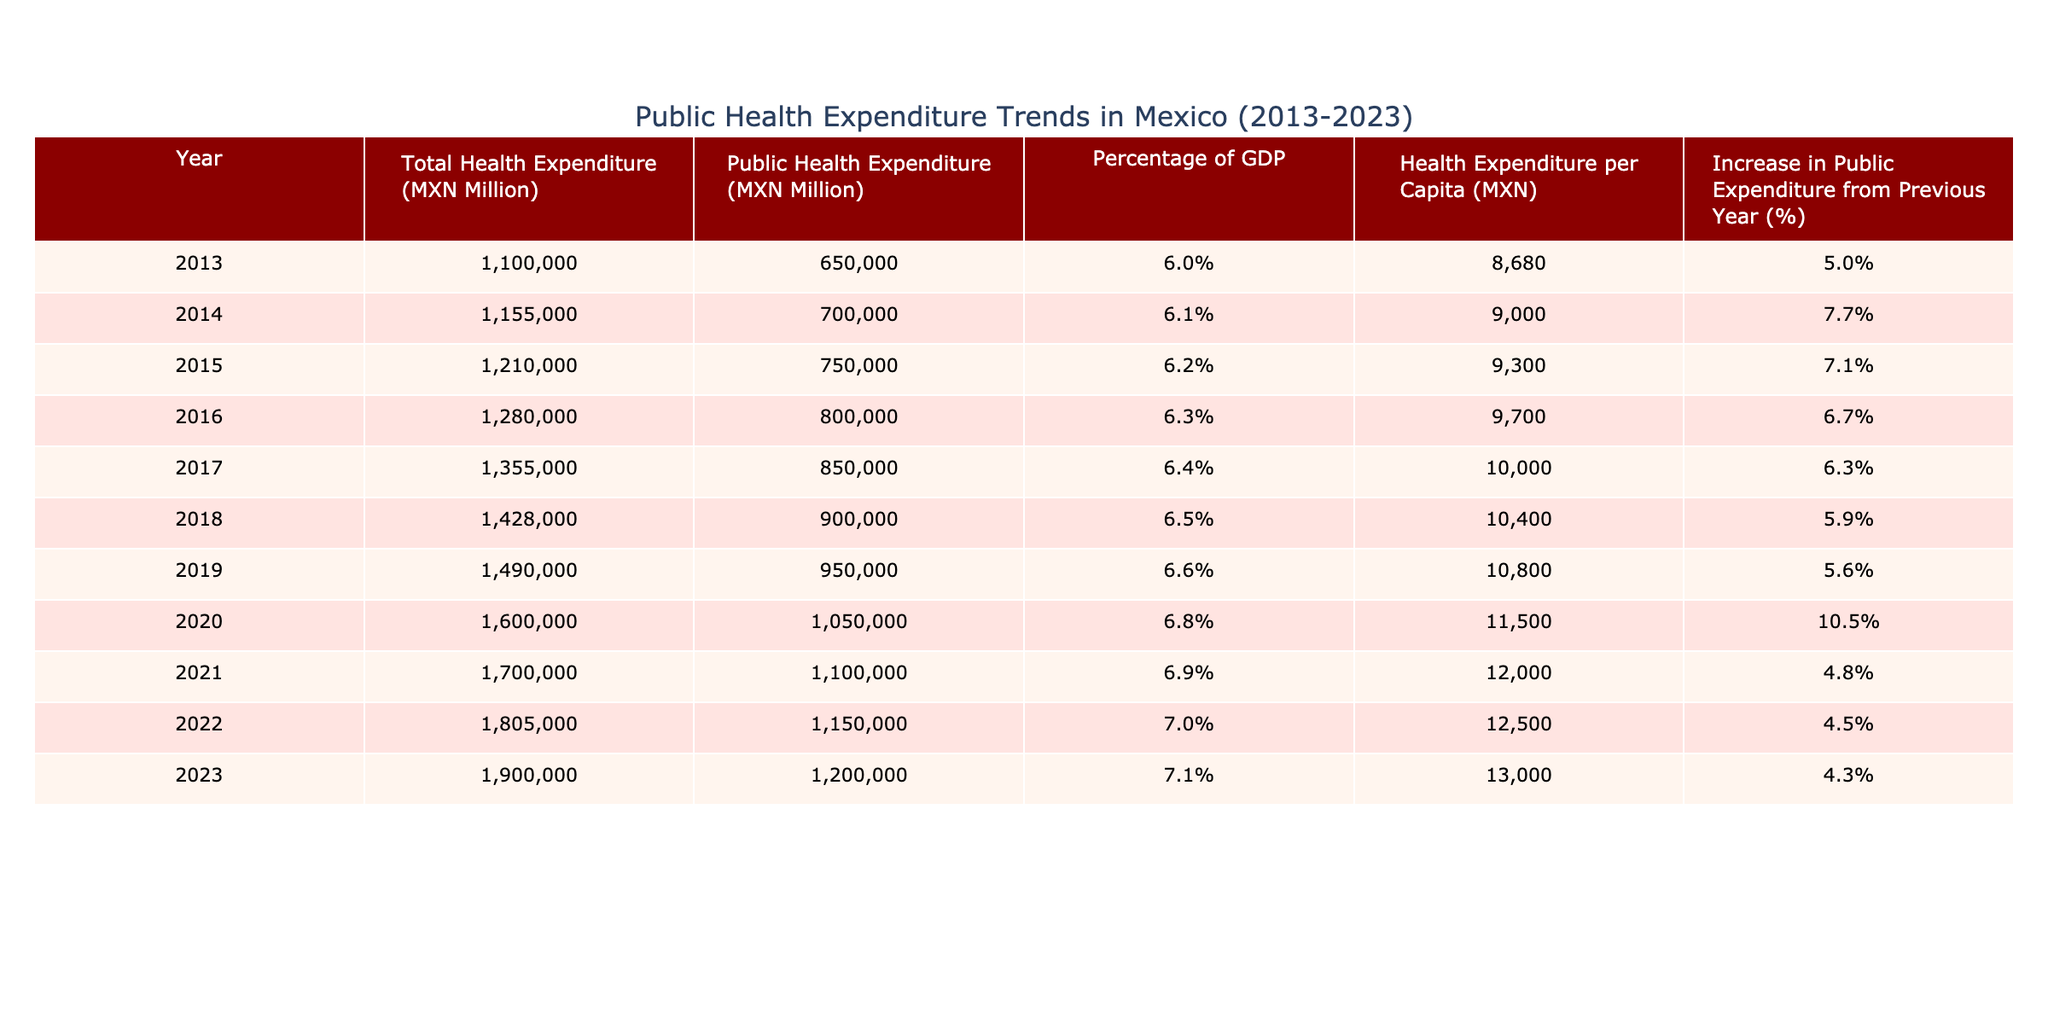What was the Public Health Expenditure in 2020? In the year 2020, the table shows that the Public Health Expenditure was 1,050,000 MXN Million.
Answer: 1,050,000 MXN Million What was the percentage increase in Public Expenditure from 2019 to 2020? The increase in Public Expenditure from 2019 (950,000 MXN Million) to 2020 (1,050,000 MXN Million) is calculated as (1,050,000 - 950,000) / 950,000 * 100 = 10.5%.
Answer: 10.5% Is the Health Expenditure per Capita higher in 2023 than in 2018? In 2023, the Health Expenditure per Capita is 13,000 MXN, while in 2018 it is 10,400 MXN. Since 13,000 is greater than 10,400, the statement is true.
Answer: Yes What is the average increase in Public Expenditure over the last 5 years (2019-2023)? The increases in Public Expenditure from 2019 to 2023 are: 5.6% (2019 to 2020), 10.5% (2020 to 2021), 4.8% (2021 to 2022), 4.5% (2022 to 2023). Calculating the average gives (5.6 + 10.5 + 4.8 + 4.5) / 4 = 6.4%.
Answer: 6.4% Was the Total Health Expenditure in 2013 less than 1,100,000 MXN Million? The Total Health Expenditure in 2013 is listed as 1,100,000 MXN Million. Since it is equal to 1,100,000, the statement is false.
Answer: No What has been the trend in the Percentage of GDP attributed to health expenditure from 2013 to 2023? The Percentage of GDP attributed to health expenditure increased from 6.0% in 2013 to 7.1% in 2023, indicating a general upward trend in health expenditure relative to GDP over this period.
Answer: Upward trend What is the total Public Health Expenditure from 2013 to 2022? To find the total Public Health Expenditure, we sum the values from 2013 to 2022: 650,000 + 700,000 + 750,000 + 800,000 + 850,000 + 900,000 + 950,000 + 1,100,000 + 1,150,000 = 7,000,000 MXN Million.
Answer: 7,000,000 MXN Million In which year was the highest Public Health Expenditure recorded? The highest Public Health Expenditure recorded in the table is 1,200,000 MXN Million in the year 2023.
Answer: 2023 What was the increase in Public Expenditure from 2013 to 2017? To find this, subtract the Public Expenditure in 2013 (650,000) from that in 2017 (850,000): 850,000 - 650,000 = 200,000 MXN Million. The increase is thus 200,000 MXN Million.
Answer: 200,000 MXN Million 